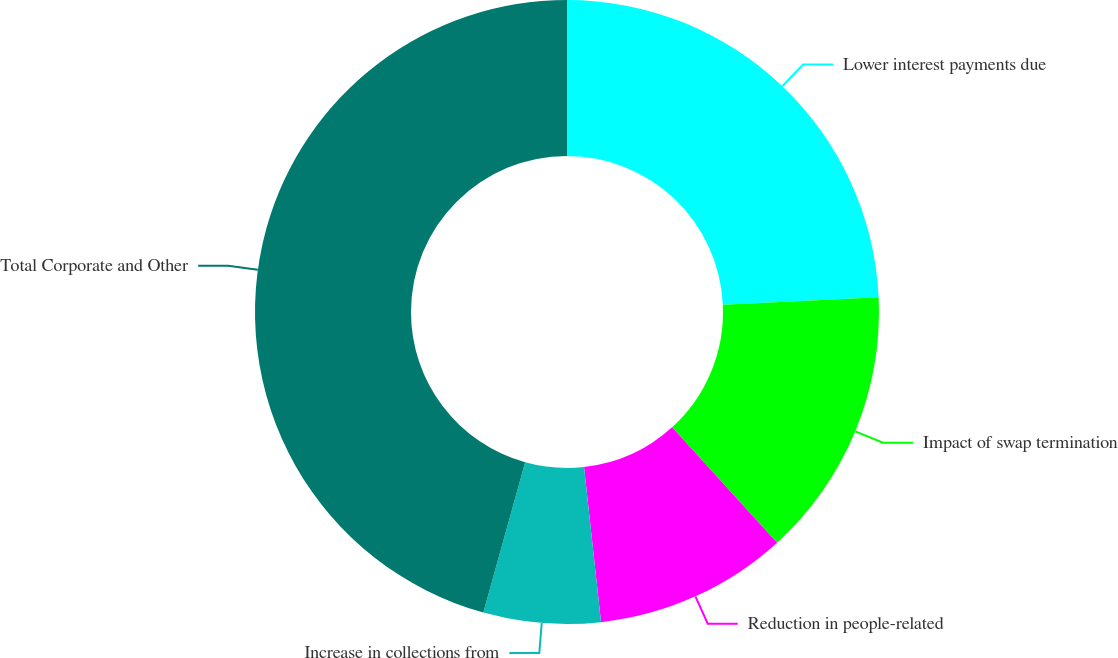Convert chart to OTSL. <chart><loc_0><loc_0><loc_500><loc_500><pie_chart><fcel>Lower interest payments due<fcel>Impact of swap termination<fcel>Reduction in people-related<fcel>Increase in collections from<fcel>Total Corporate and Other<nl><fcel>24.25%<fcel>13.99%<fcel>10.02%<fcel>6.06%<fcel>45.68%<nl></chart> 